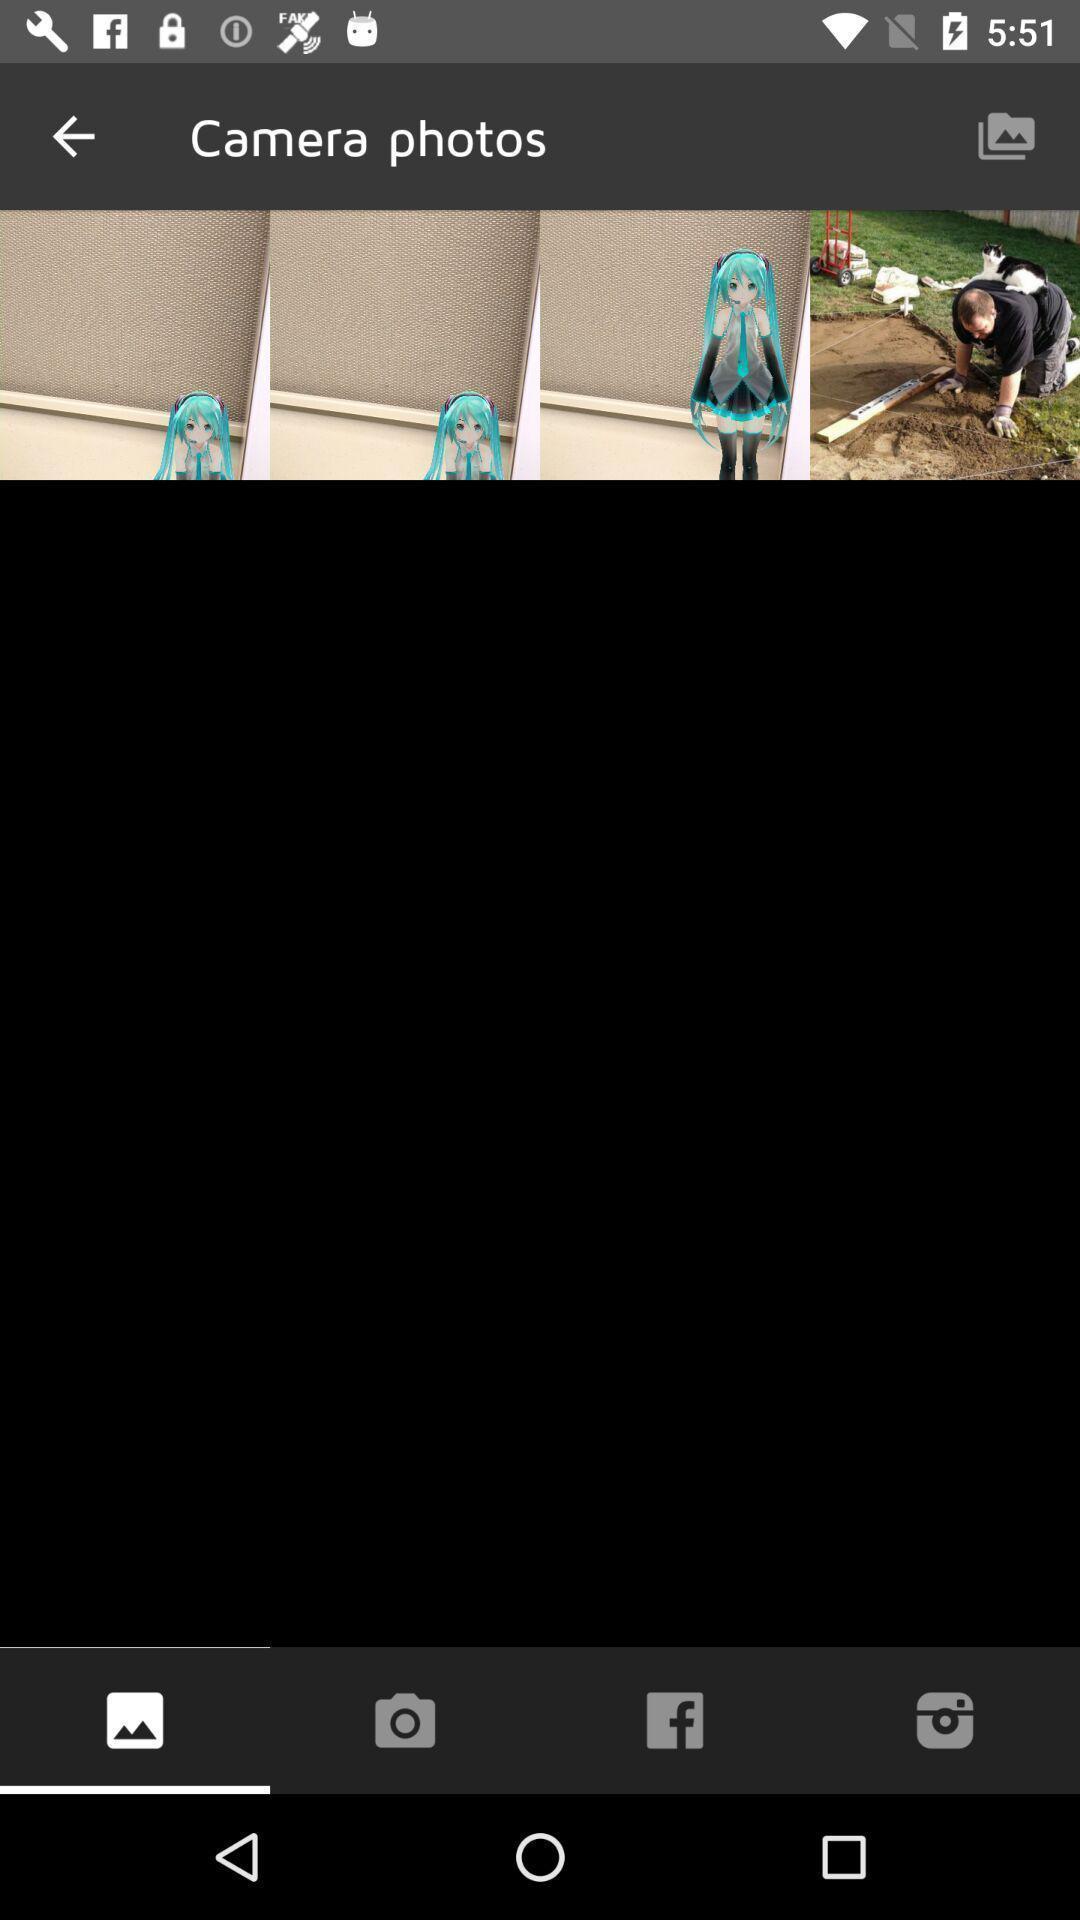What details can you identify in this image? Screen displaying the camera photos. 